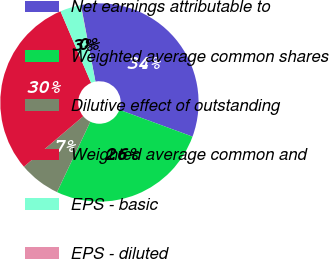Convert chart. <chart><loc_0><loc_0><loc_500><loc_500><pie_chart><fcel>Net earnings attributable to<fcel>Weighted average common shares<fcel>Dilutive effect of outstanding<fcel>Weighted average common and<fcel>EPS - basic<fcel>EPS - diluted<nl><fcel>33.58%<fcel>26.44%<fcel>6.75%<fcel>29.79%<fcel>3.4%<fcel>0.04%<nl></chart> 